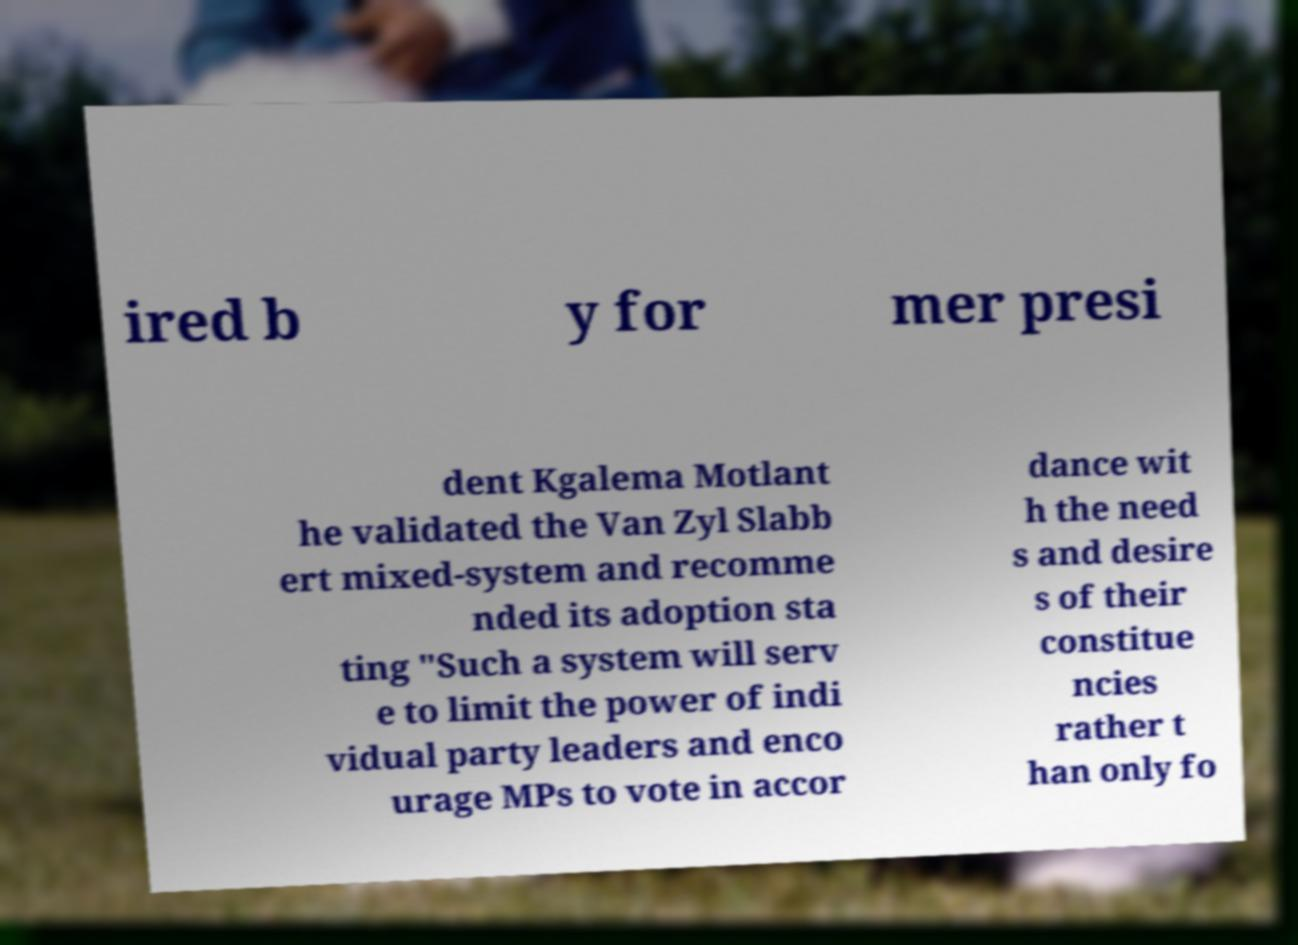Please identify and transcribe the text found in this image. ired b y for mer presi dent Kgalema Motlant he validated the Van Zyl Slabb ert mixed-system and recomme nded its adoption sta ting "Such a system will serv e to limit the power of indi vidual party leaders and enco urage MPs to vote in accor dance wit h the need s and desire s of their constitue ncies rather t han only fo 